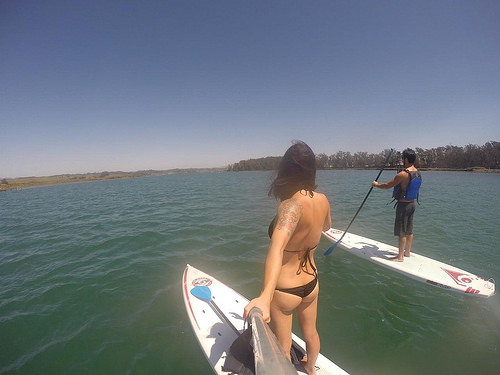<image>
Can you confirm if the man is to the left of the women? No. The man is not to the left of the women. From this viewpoint, they have a different horizontal relationship. Is the woman in the water? No. The woman is not contained within the water. These objects have a different spatial relationship. 